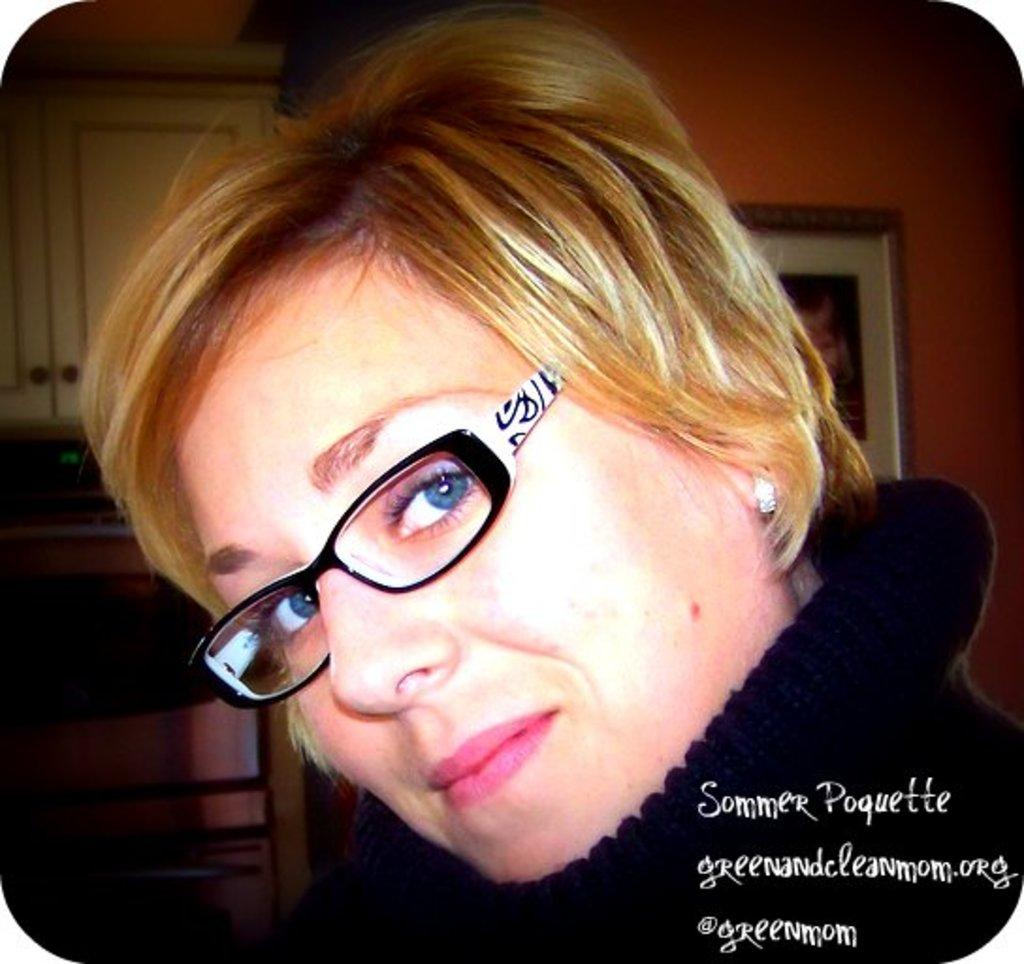Who is the main subject in the image? There is a woman in the image. What is the woman wearing that is visible in the image? The woman is wearing spectacles. What can be seen on the wall behind the woman? There is a frame on the wall behind the woman. Where is the text located in the image? The text is in the bottom right-hand corner of the image. What type of throat lozenges does the woman have in her hand in the image? There is no indication in the image that the woman has any throat lozenges or is experiencing any throat-related issues. 